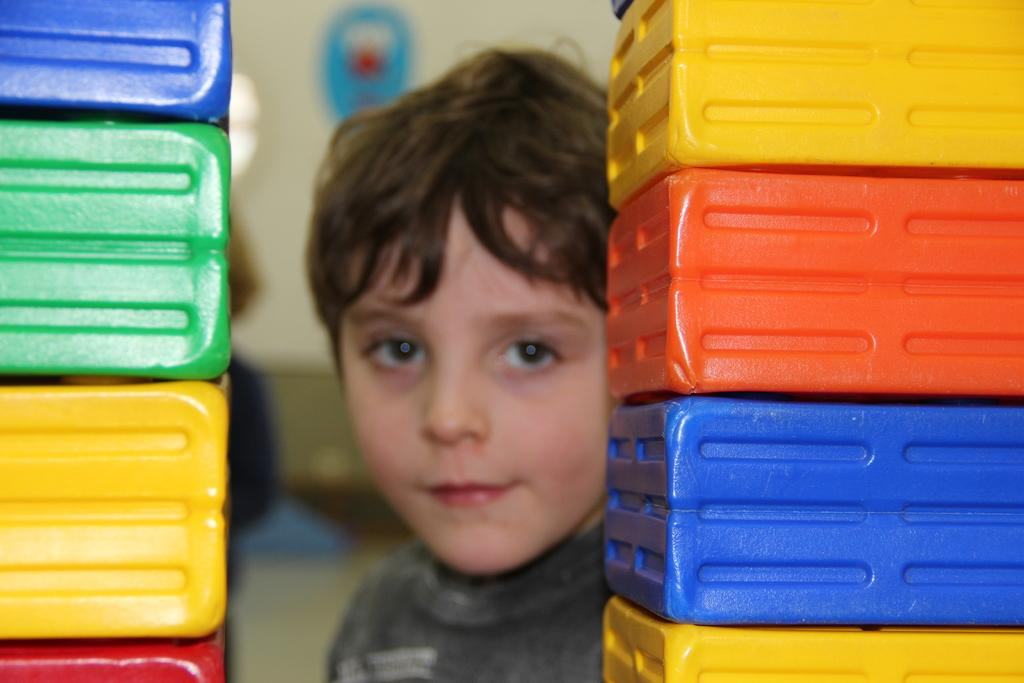What type of containers are visible in the image? There are plastic boxes in the image. How are the plastic boxes arranged? The plastic boxes are arranged one upon another. Can you describe the position of the boy in the image? There is a boy behind the plastic boxes. What type of religious ceremony is taking place behind the plastic boxes? There is no indication of a religious ceremony or any religious elements in the image. 